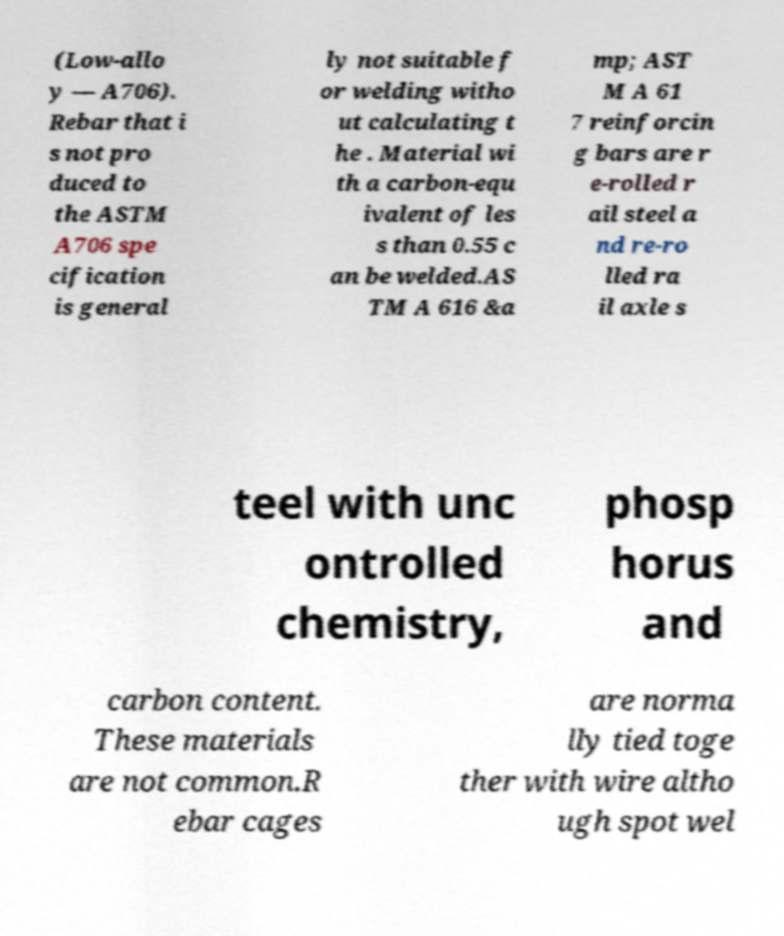Please read and relay the text visible in this image. What does it say? (Low-allo y — A706). Rebar that i s not pro duced to the ASTM A706 spe cification is general ly not suitable f or welding witho ut calculating t he . Material wi th a carbon-equ ivalent of les s than 0.55 c an be welded.AS TM A 616 &a mp; AST M A 61 7 reinforcin g bars are r e-rolled r ail steel a nd re-ro lled ra il axle s teel with unc ontrolled chemistry, phosp horus and carbon content. These materials are not common.R ebar cages are norma lly tied toge ther with wire altho ugh spot wel 